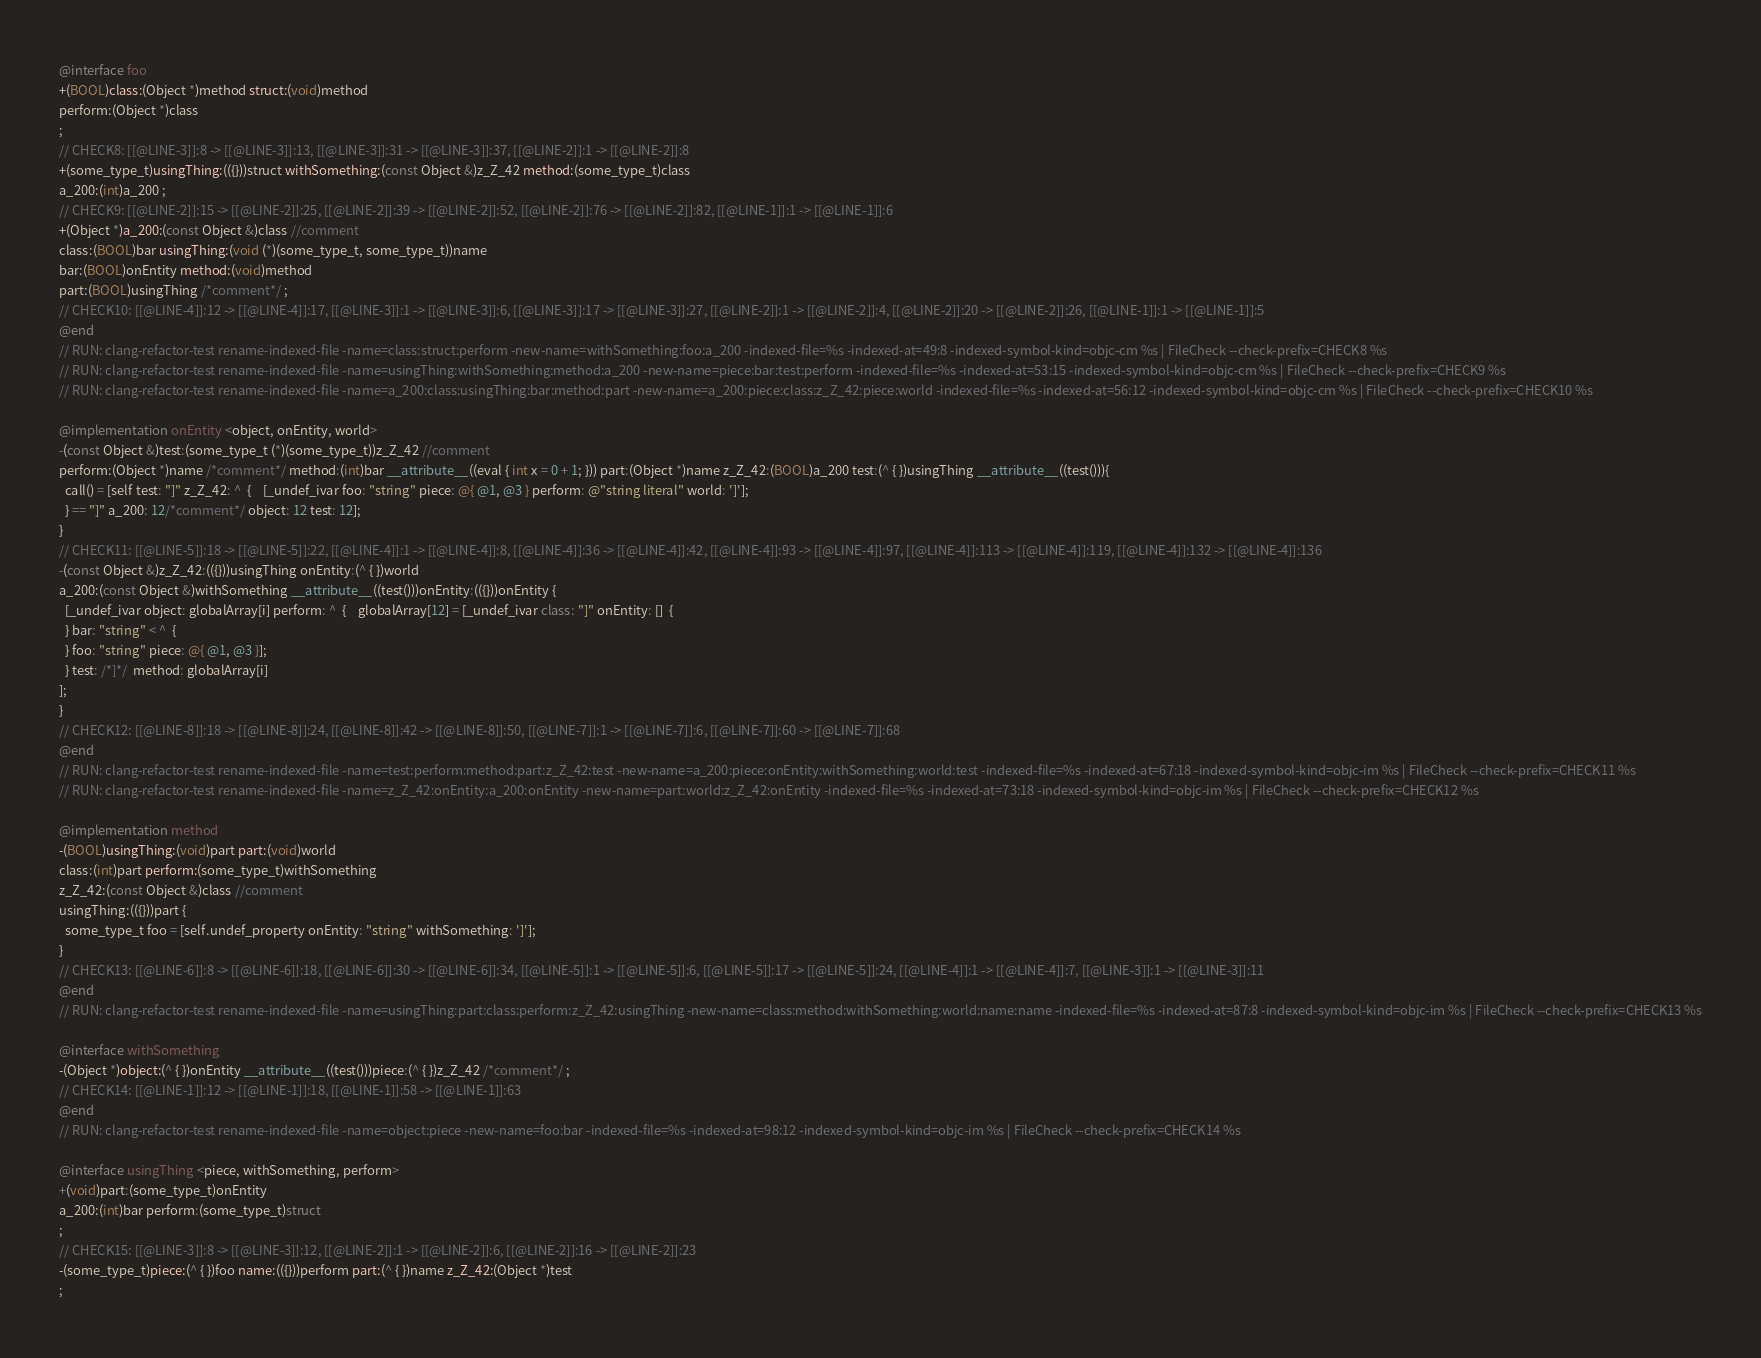Convert code to text. <code><loc_0><loc_0><loc_500><loc_500><_ObjectiveC_>@interface foo
+(BOOL)class:(Object *)method struct:(void)method
perform:(Object *)class
;
// CHECK8: [[@LINE-3]]:8 -> [[@LINE-3]]:13, [[@LINE-3]]:31 -> [[@LINE-3]]:37, [[@LINE-2]]:1 -> [[@LINE-2]]:8
+(some_type_t)usingThing:(({}))struct withSomething:(const Object &)z_Z_42 method:(some_type_t)class
a_200:(int)a_200 ;
// CHECK9: [[@LINE-2]]:15 -> [[@LINE-2]]:25, [[@LINE-2]]:39 -> [[@LINE-2]]:52, [[@LINE-2]]:76 -> [[@LINE-2]]:82, [[@LINE-1]]:1 -> [[@LINE-1]]:6
+(Object *)a_200:(const Object &)class //comment
class:(BOOL)bar usingThing:(void (*)(some_type_t, some_type_t))name
bar:(BOOL)onEntity method:(void)method
part:(BOOL)usingThing /*comment*/ ;
// CHECK10: [[@LINE-4]]:12 -> [[@LINE-4]]:17, [[@LINE-3]]:1 -> [[@LINE-3]]:6, [[@LINE-3]]:17 -> [[@LINE-3]]:27, [[@LINE-2]]:1 -> [[@LINE-2]]:4, [[@LINE-2]]:20 -> [[@LINE-2]]:26, [[@LINE-1]]:1 -> [[@LINE-1]]:5
@end
// RUN: clang-refactor-test rename-indexed-file -name=class:struct:perform -new-name=withSomething:foo:a_200 -indexed-file=%s -indexed-at=49:8 -indexed-symbol-kind=objc-cm %s | FileCheck --check-prefix=CHECK8 %s
// RUN: clang-refactor-test rename-indexed-file -name=usingThing:withSomething:method:a_200 -new-name=piece:bar:test:perform -indexed-file=%s -indexed-at=53:15 -indexed-symbol-kind=objc-cm %s | FileCheck --check-prefix=CHECK9 %s
// RUN: clang-refactor-test rename-indexed-file -name=a_200:class:usingThing:bar:method:part -new-name=a_200:piece:class:z_Z_42:piece:world -indexed-file=%s -indexed-at=56:12 -indexed-symbol-kind=objc-cm %s | FileCheck --check-prefix=CHECK10 %s

@implementation onEntity <object, onEntity, world>
-(const Object &)test:(some_type_t (*)(some_type_t))z_Z_42 //comment
perform:(Object *)name /*comment*/ method:(int)bar __attribute__((eval { int x = 0 + 1; })) part:(Object *)name z_Z_42:(BOOL)a_200 test:(^ { })usingThing __attribute__((test())){
  call() = [self test: "]" z_Z_42: ^  {    [_undef_ivar foo: "string" piece: @{ @1, @3 } perform: @"string literal" world: ']'];
  } == "]" a_200: 12/*comment*/ object: 12 test: 12];
}
// CHECK11: [[@LINE-5]]:18 -> [[@LINE-5]]:22, [[@LINE-4]]:1 -> [[@LINE-4]]:8, [[@LINE-4]]:36 -> [[@LINE-4]]:42, [[@LINE-4]]:93 -> [[@LINE-4]]:97, [[@LINE-4]]:113 -> [[@LINE-4]]:119, [[@LINE-4]]:132 -> [[@LINE-4]]:136
-(const Object &)z_Z_42:(({}))usingThing onEntity:(^ { })world
a_200:(const Object &)withSomething __attribute__((test()))onEntity:(({}))onEntity {
  [_undef_ivar object: globalArray[i] perform: ^  {    globalArray[12] = [_undef_ivar class: "]" onEntity: []  {
  } bar: "string" < ^  {
  } foo: "string" piece: @{ @1, @3 }];
  } test: /*]*/  method: globalArray[i]
];
}
// CHECK12: [[@LINE-8]]:18 -> [[@LINE-8]]:24, [[@LINE-8]]:42 -> [[@LINE-8]]:50, [[@LINE-7]]:1 -> [[@LINE-7]]:6, [[@LINE-7]]:60 -> [[@LINE-7]]:68
@end
// RUN: clang-refactor-test rename-indexed-file -name=test:perform:method:part:z_Z_42:test -new-name=a_200:piece:onEntity:withSomething:world:test -indexed-file=%s -indexed-at=67:18 -indexed-symbol-kind=objc-im %s | FileCheck --check-prefix=CHECK11 %s
// RUN: clang-refactor-test rename-indexed-file -name=z_Z_42:onEntity:a_200:onEntity -new-name=part:world:z_Z_42:onEntity -indexed-file=%s -indexed-at=73:18 -indexed-symbol-kind=objc-im %s | FileCheck --check-prefix=CHECK12 %s

@implementation method
-(BOOL)usingThing:(void)part part:(void)world
class:(int)part perform:(some_type_t)withSomething
z_Z_42:(const Object &)class //comment
usingThing:(({}))part {
  some_type_t foo = [self.undef_property onEntity: "string" withSomething: ']'];
}
// CHECK13: [[@LINE-6]]:8 -> [[@LINE-6]]:18, [[@LINE-6]]:30 -> [[@LINE-6]]:34, [[@LINE-5]]:1 -> [[@LINE-5]]:6, [[@LINE-5]]:17 -> [[@LINE-5]]:24, [[@LINE-4]]:1 -> [[@LINE-4]]:7, [[@LINE-3]]:1 -> [[@LINE-3]]:11
@end
// RUN: clang-refactor-test rename-indexed-file -name=usingThing:part:class:perform:z_Z_42:usingThing -new-name=class:method:withSomething:world:name:name -indexed-file=%s -indexed-at=87:8 -indexed-symbol-kind=objc-im %s | FileCheck --check-prefix=CHECK13 %s

@interface withSomething
-(Object *)object:(^ { })onEntity __attribute__((test()))piece:(^ { })z_Z_42 /*comment*/ ;
// CHECK14: [[@LINE-1]]:12 -> [[@LINE-1]]:18, [[@LINE-1]]:58 -> [[@LINE-1]]:63
@end
// RUN: clang-refactor-test rename-indexed-file -name=object:piece -new-name=foo:bar -indexed-file=%s -indexed-at=98:12 -indexed-symbol-kind=objc-im %s | FileCheck --check-prefix=CHECK14 %s

@interface usingThing <piece, withSomething, perform>
+(void)part:(some_type_t)onEntity
a_200:(int)bar perform:(some_type_t)struct
;
// CHECK15: [[@LINE-3]]:8 -> [[@LINE-3]]:12, [[@LINE-2]]:1 -> [[@LINE-2]]:6, [[@LINE-2]]:16 -> [[@LINE-2]]:23
-(some_type_t)piece:(^ { })foo name:(({}))perform part:(^ { })name z_Z_42:(Object *)test
;</code> 